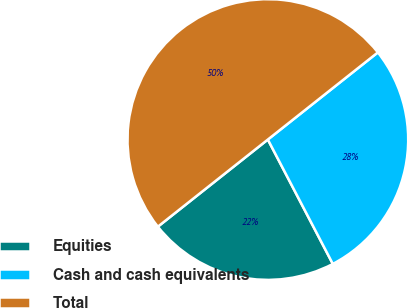<chart> <loc_0><loc_0><loc_500><loc_500><pie_chart><fcel>Equities<fcel>Cash and cash equivalents<fcel>Total<nl><fcel>22.0%<fcel>28.0%<fcel>50.0%<nl></chart> 